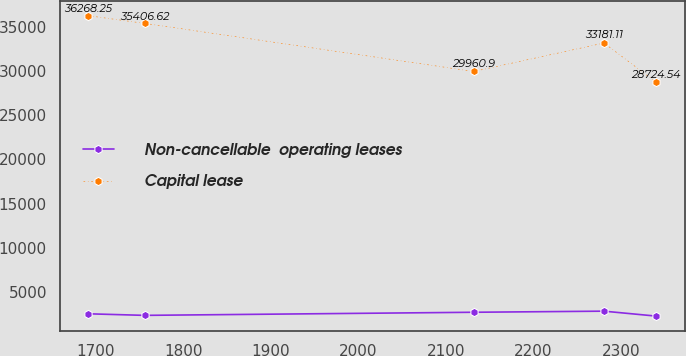Convert chart. <chart><loc_0><loc_0><loc_500><loc_500><line_chart><ecel><fcel>Non-cancellable  operating leases<fcel>Capital lease<nl><fcel>1691.83<fcel>2538.9<fcel>36268.2<nl><fcel>1755.89<fcel>2362.37<fcel>35406.6<nl><fcel>2131.92<fcel>2713.46<fcel>29960.9<nl><fcel>2280.66<fcel>2837.6<fcel>33181.1<nl><fcel>2340.44<fcel>2277.28<fcel>28724.5<nl></chart> 